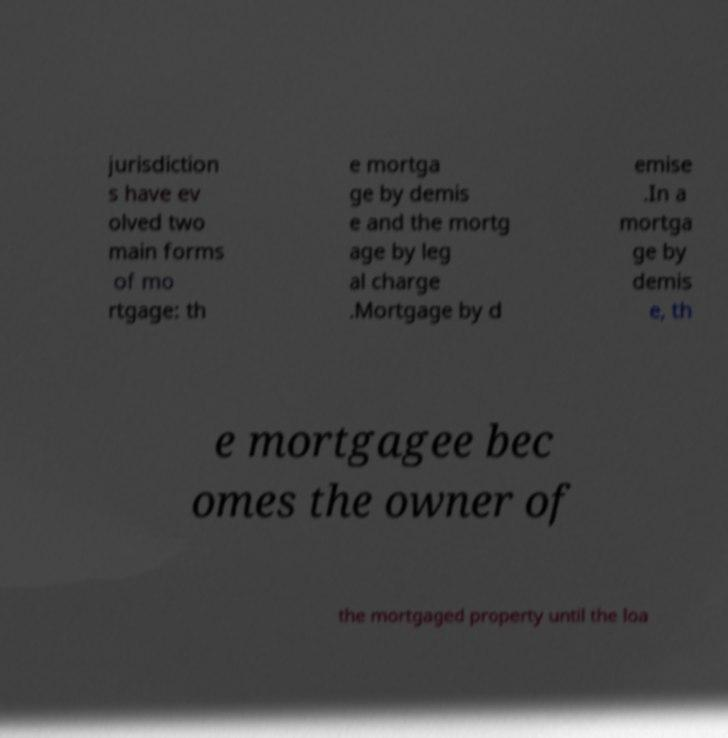Can you accurately transcribe the text from the provided image for me? jurisdiction s have ev olved two main forms of mo rtgage: th e mortga ge by demis e and the mortg age by leg al charge .Mortgage by d emise .In a mortga ge by demis e, th e mortgagee bec omes the owner of the mortgaged property until the loa 